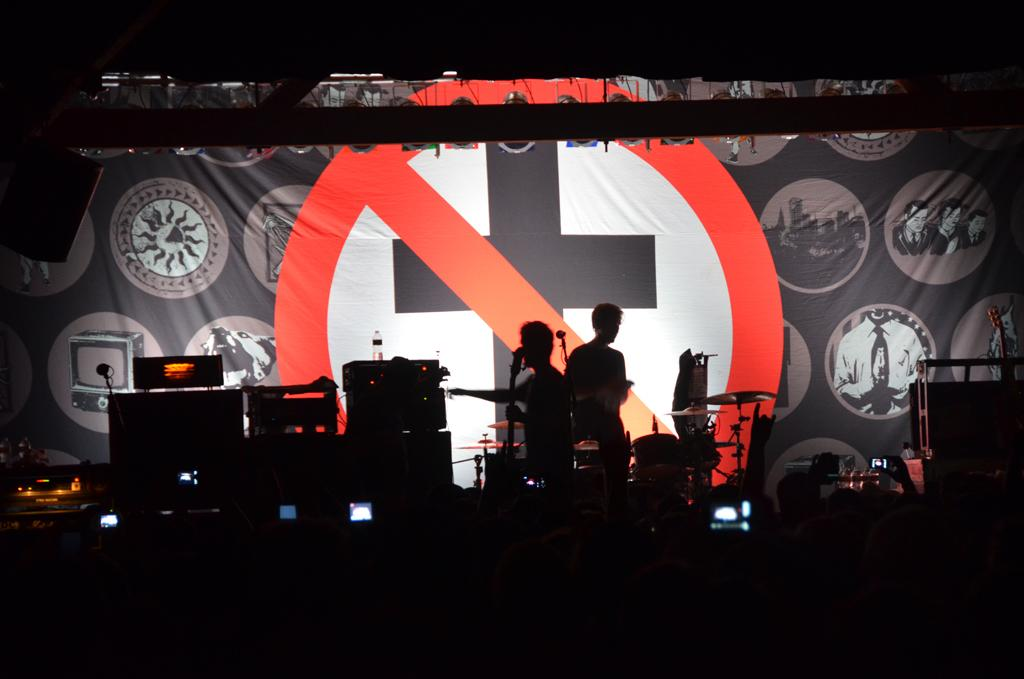What is the lighting condition in the image? The image is taken in the dark. How many people are in the image? There are two persons standing in the image. What are the musical instruments in the image used for? The musical instruments in the image are used for playing music. Can you describe any objects in the image? There are some objects in the image, but their specific details are not mentioned in the facts. What is visible in the background of the image? There is a banner in the background of the image. How many numbers are visible on the banner in the image? There is no information about numbers on the banner in the image. What type of order is being followed by the persons in the image? There is no information about any order being followed by the persons in the image. 